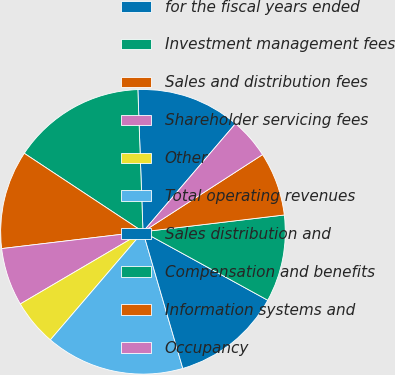<chart> <loc_0><loc_0><loc_500><loc_500><pie_chart><fcel>for the fiscal years ended<fcel>Investment management fees<fcel>Sales and distribution fees<fcel>Shareholder servicing fees<fcel>Other<fcel>Total operating revenues<fcel>Sales distribution and<fcel>Compensation and benefits<fcel>Information systems and<fcel>Occupancy<nl><fcel>11.84%<fcel>15.13%<fcel>11.18%<fcel>6.58%<fcel>5.26%<fcel>15.79%<fcel>12.5%<fcel>9.87%<fcel>7.24%<fcel>4.61%<nl></chart> 